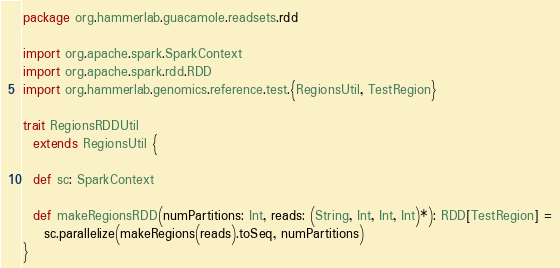<code> <loc_0><loc_0><loc_500><loc_500><_Scala_>package org.hammerlab.guacamole.readsets.rdd

import org.apache.spark.SparkContext
import org.apache.spark.rdd.RDD
import org.hammerlab.genomics.reference.test.{RegionsUtil, TestRegion}

trait RegionsRDDUtil
  extends RegionsUtil {

  def sc: SparkContext

  def makeRegionsRDD(numPartitions: Int, reads: (String, Int, Int, Int)*): RDD[TestRegion] =
    sc.parallelize(makeRegions(reads).toSeq, numPartitions)
}
</code> 